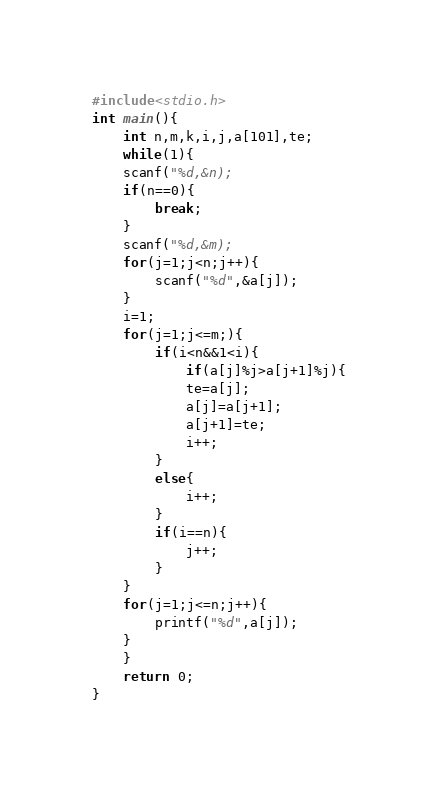Convert code to text. <code><loc_0><loc_0><loc_500><loc_500><_C_>#include<stdio.h>
int main(){
	int n,m,k,i,j,a[101],te;
	while(1){
	scanf("%d,&n);
	if(n==0){
		break;
	}
	scanf("%d,&m);
	for(j=1;j<n;j++){
		scanf("%d",&a[j]);
	}
	i=1;
	for(j=1;j<=m;){
		if(i<n&&1<i){
			if(a[j]%j>a[j+1]%j){
			te=a[j];
			a[j]=a[j+1];
			a[j+1]=te;
			i++;
		}
		else{
			i++;
		}
		if(i==n){
			j++;
		}
	}
	for(j=1;j<=n;j++){
		printf("%d",a[j]);
	}
	}
	return 0;
}</code> 